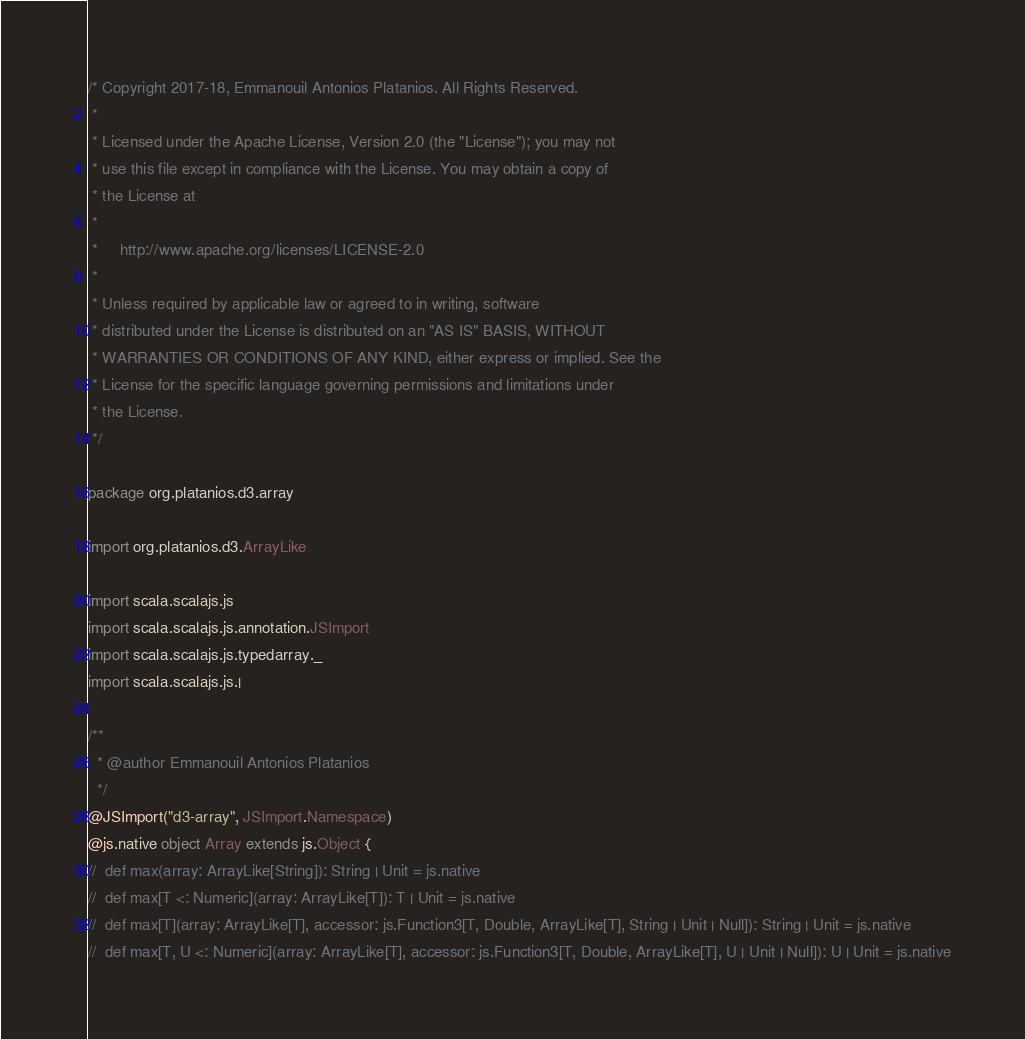Convert code to text. <code><loc_0><loc_0><loc_500><loc_500><_Scala_>/* Copyright 2017-18, Emmanouil Antonios Platanios. All Rights Reserved.
 *
 * Licensed under the Apache License, Version 2.0 (the "License"); you may not
 * use this file except in compliance with the License. You may obtain a copy of
 * the License at
 *
 *     http://www.apache.org/licenses/LICENSE-2.0
 *
 * Unless required by applicable law or agreed to in writing, software
 * distributed under the License is distributed on an "AS IS" BASIS, WITHOUT
 * WARRANTIES OR CONDITIONS OF ANY KIND, either express or implied. See the
 * License for the specific language governing permissions and limitations under
 * the License.
 */

package org.platanios.d3.array

import org.platanios.d3.ArrayLike

import scala.scalajs.js
import scala.scalajs.js.annotation.JSImport
import scala.scalajs.js.typedarray._
import scala.scalajs.js.|

/**
  * @author Emmanouil Antonios Platanios
  */
@JSImport("d3-array", JSImport.Namespace)
@js.native object Array extends js.Object {
//  def max(array: ArrayLike[String]): String | Unit = js.native
//  def max[T <: Numeric](array: ArrayLike[T]): T | Unit = js.native
//  def max[T](array: ArrayLike[T], accessor: js.Function3[T, Double, ArrayLike[T], String | Unit | Null]): String | Unit = js.native
//  def max[T, U <: Numeric](array: ArrayLike[T], accessor: js.Function3[T, Double, ArrayLike[T], U | Unit | Null]): U | Unit = js.native
</code> 